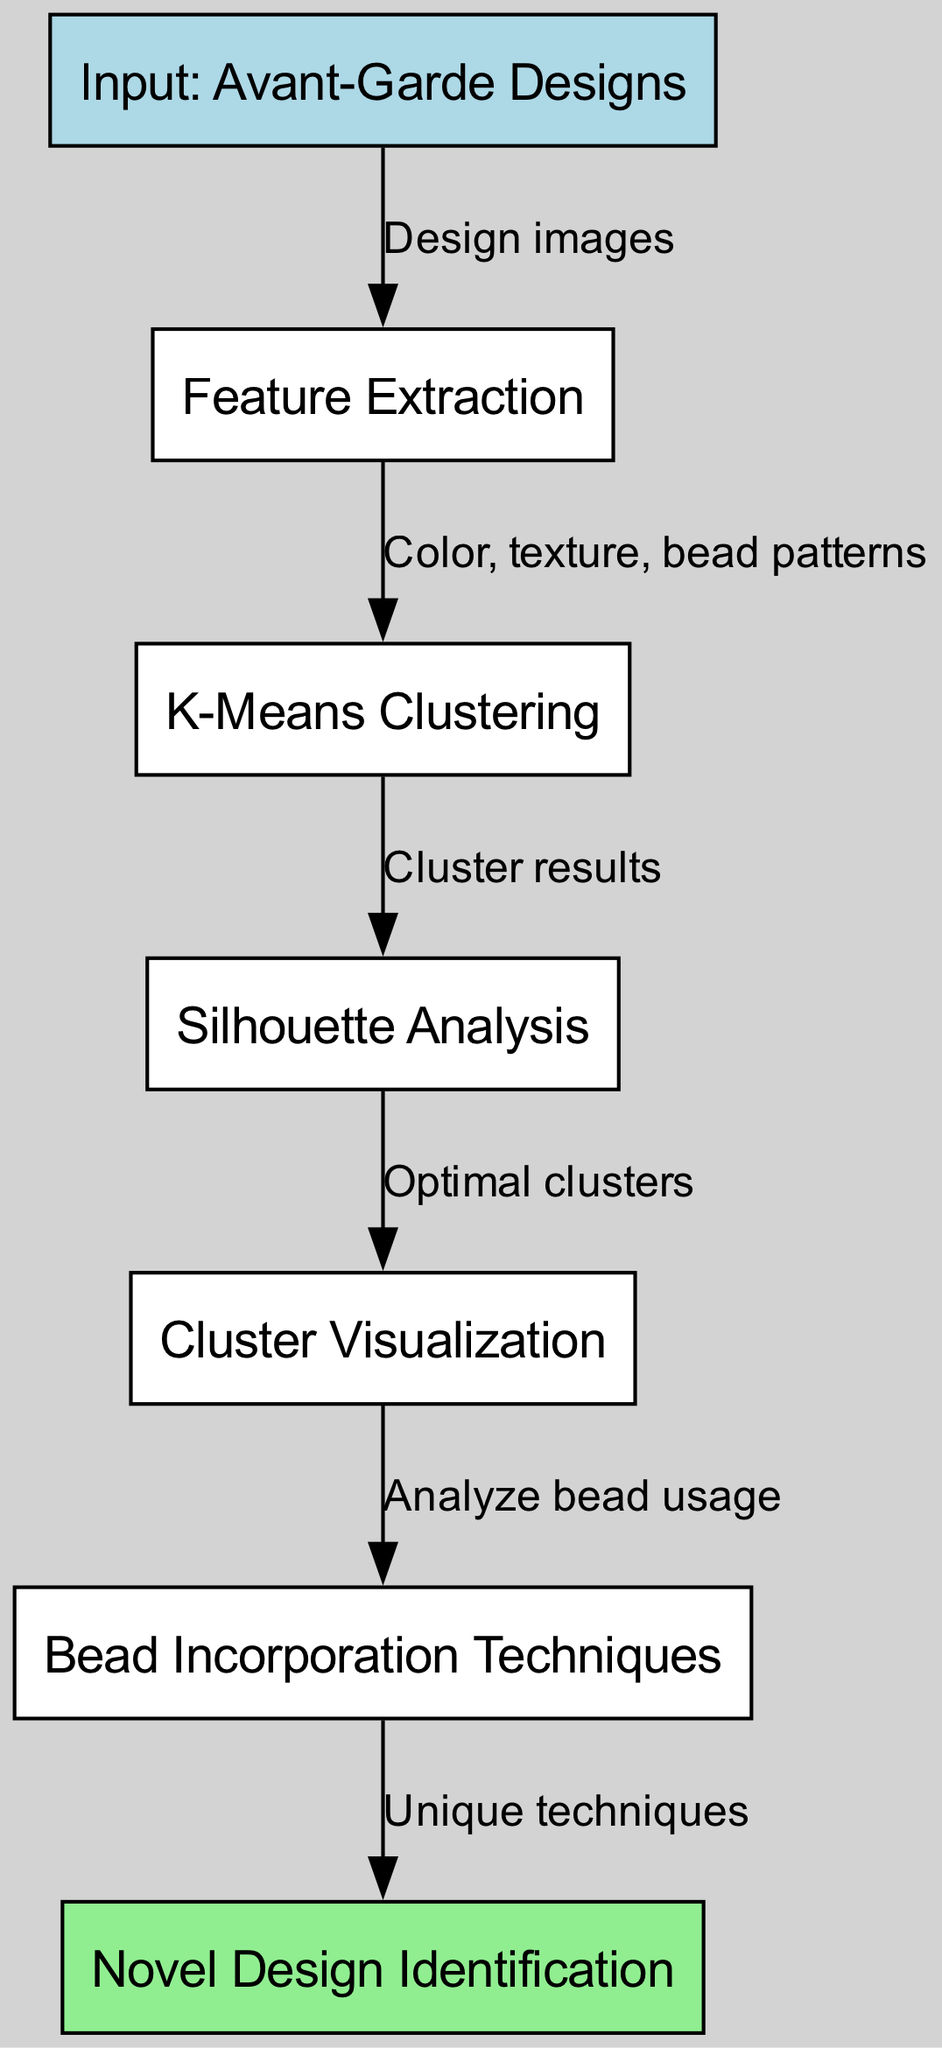What is the first step in the diagram? The diagram starts with the node "Input: Avant-Garde Designs," which represents the initial stage of the process before any analysis or clustering is performed.
Answer: Input: Avant-Garde Designs How many nodes are in the diagram? The diagram contains a total of 7 nodes, each representing a distinct step or concept in the clustering process for avant-garde designs.
Answer: 7 What does the node labeled "5" represent? Node "5" is labeled "Cluster Visualization," indicating that this step involves visualizing the results of the clustering process and interpreting the structure of the identified clusters.
Answer: Cluster Visualization What is the relationship between node "3" and node "4"? The edge connects node "3" (K-Means Clustering) to node "4" (Silhouette Analysis) and shows that the cluster results obtained from K-Means Clustering are used for Silhouette Analysis to evaluate the quality of the clusters.
Answer: Cluster results What type of analysis is performed after clustering? After clustering, "Silhouette Analysis" is performed to assess the optimality and separateness of the clusters obtained through the K-Means algorithm.
Answer: Silhouette Analysis Which node analyzes bead usage? Node "5" (Cluster Visualization) leads to node "6" (Bead Incorporation Techniques), where the analysis of bead usage within the identified clusters takes place to identify patterns in the designs.
Answer: Bead Incorporation Techniques What do the edges from node "6" indicate? The edges originating from node "6" show that the analysis of bead usage leads to the identification of unique incorporation techniques in avant-garde designs, as represented in the next node, "Novel Design Identification."
Answer: Unique techniques 